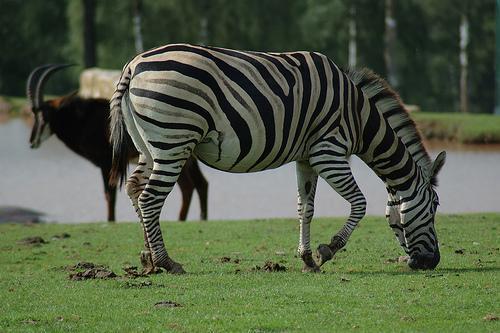How many zebras are there?
Give a very brief answer. 1. How many goats are there?
Give a very brief answer. 1. How many animals are shown?
Give a very brief answer. 2. How many zebras are shown?
Give a very brief answer. 1. 